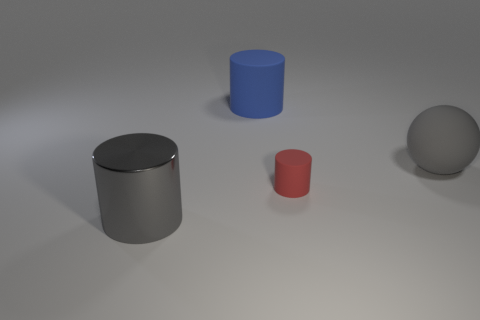Are there an equal number of big gray matte balls behind the big rubber ball and big red metal cylinders?
Offer a very short reply. Yes. Do the red matte object and the gray cylinder have the same size?
Your response must be concise. No. What color is the rubber sphere that is the same size as the gray shiny thing?
Give a very brief answer. Gray. There is a blue matte cylinder; is it the same size as the gray object that is on the left side of the tiny red rubber object?
Ensure brevity in your answer.  Yes. How many metal cylinders are the same color as the rubber ball?
Give a very brief answer. 1. How many things are either gray metal cylinders or things that are in front of the blue matte cylinder?
Make the answer very short. 3. There is a gray thing right of the shiny cylinder; does it have the same size as the blue object that is on the left side of the gray matte thing?
Provide a short and direct response. Yes. Are there any large brown spheres made of the same material as the blue object?
Provide a succinct answer. No. What is the shape of the tiny matte object?
Keep it short and to the point. Cylinder. The gray object that is right of the large thing that is left of the blue matte object is what shape?
Offer a terse response. Sphere. 